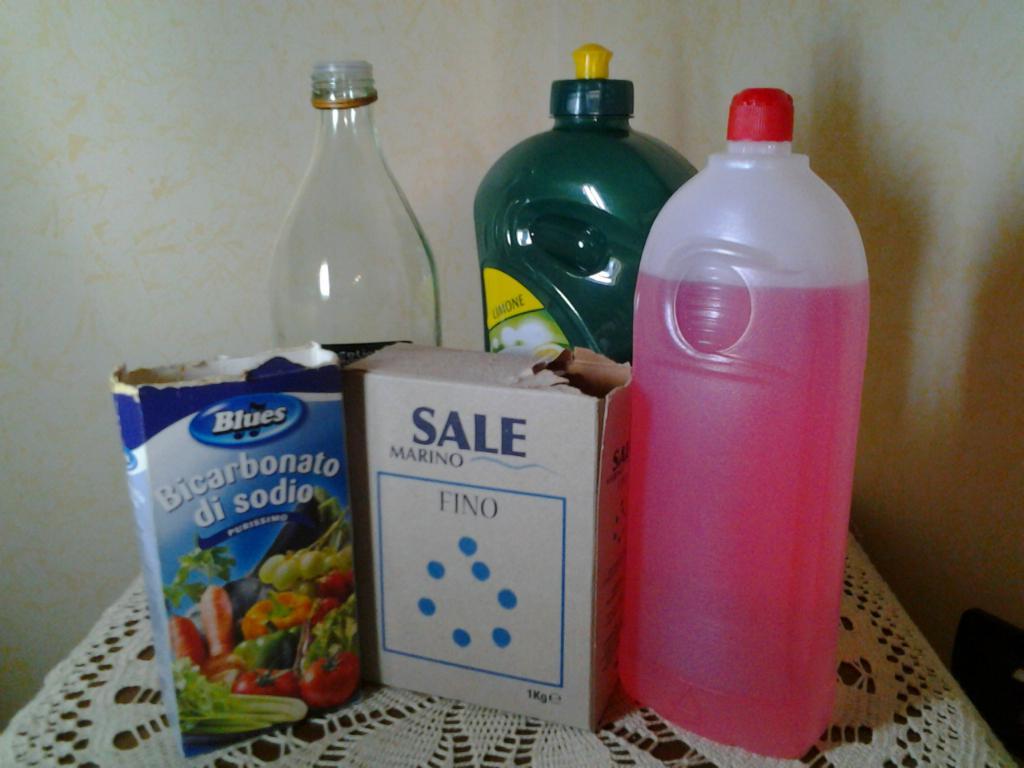What company makes fino?
Ensure brevity in your answer.  Sale marino. 